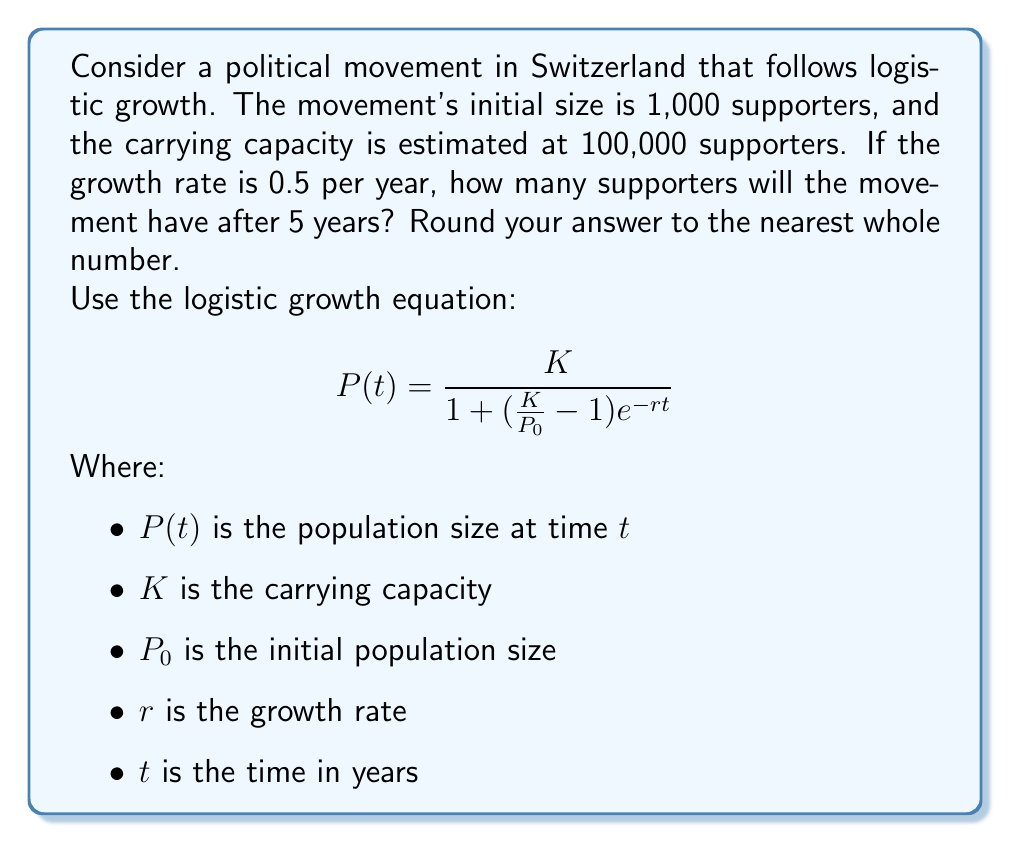Teach me how to tackle this problem. To solve this problem, we'll use the logistic growth equation and plug in the given values:

$K = 100,000$ (carrying capacity)
$P_0 = 1,000$ (initial population)
$r = 0.5$ (growth rate per year)
$t = 5$ (time in years)

Let's substitute these values into the equation:

$$P(5) = \frac{100,000}{1 + (\frac{100,000}{1,000} - 1)e^{-0.5 \cdot 5}}$$

Now, let's solve this step-by-step:

1. Simplify the fraction inside the parentheses:
   $$P(5) = \frac{100,000}{1 + (100 - 1)e^{-2.5}}$$

2. Simplify further:
   $$P(5) = \frac{100,000}{1 + 99e^{-2.5}}$$

3. Calculate $e^{-2.5}$:
   $e^{-2.5} \approx 0.0820$

4. Multiply:
   $$P(5) = \frac{100,000}{1 + 99 \cdot 0.0820}$$
   $$P(5) = \frac{100,000}{1 + 8.1180}$$

5. Add in the denominator:
   $$P(5) = \frac{100,000}{9.1180}$$

6. Divide:
   $$P(5) \approx 10,967.32$$

7. Round to the nearest whole number:
   $$P(5) \approx 10,967$$

Therefore, after 5 years, the political movement will have approximately 10,967 supporters.
Answer: 10,967 supporters 